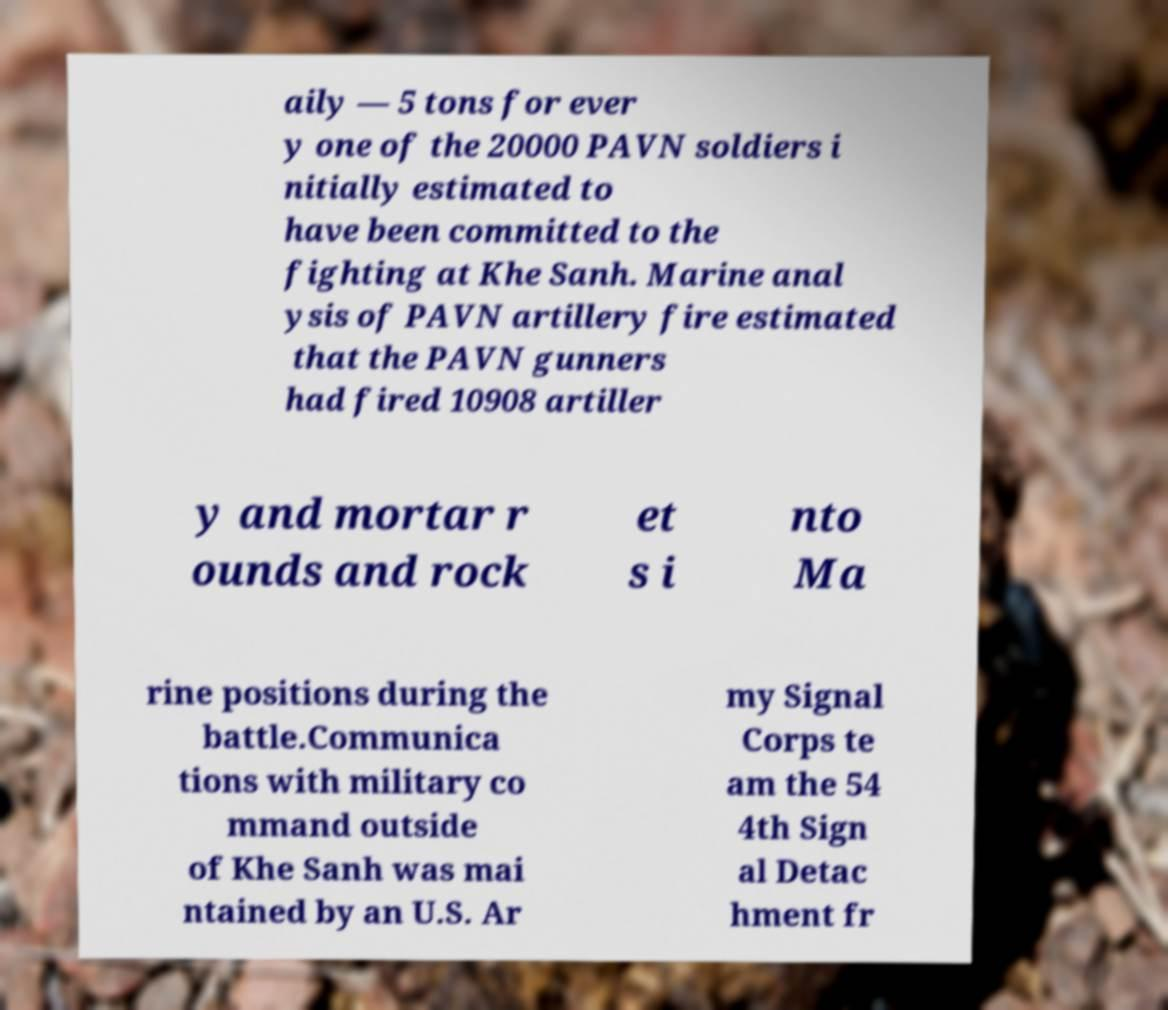There's text embedded in this image that I need extracted. Can you transcribe it verbatim? aily — 5 tons for ever y one of the 20000 PAVN soldiers i nitially estimated to have been committed to the fighting at Khe Sanh. Marine anal ysis of PAVN artillery fire estimated that the PAVN gunners had fired 10908 artiller y and mortar r ounds and rock et s i nto Ma rine positions during the battle.Communica tions with military co mmand outside of Khe Sanh was mai ntained by an U.S. Ar my Signal Corps te am the 54 4th Sign al Detac hment fr 